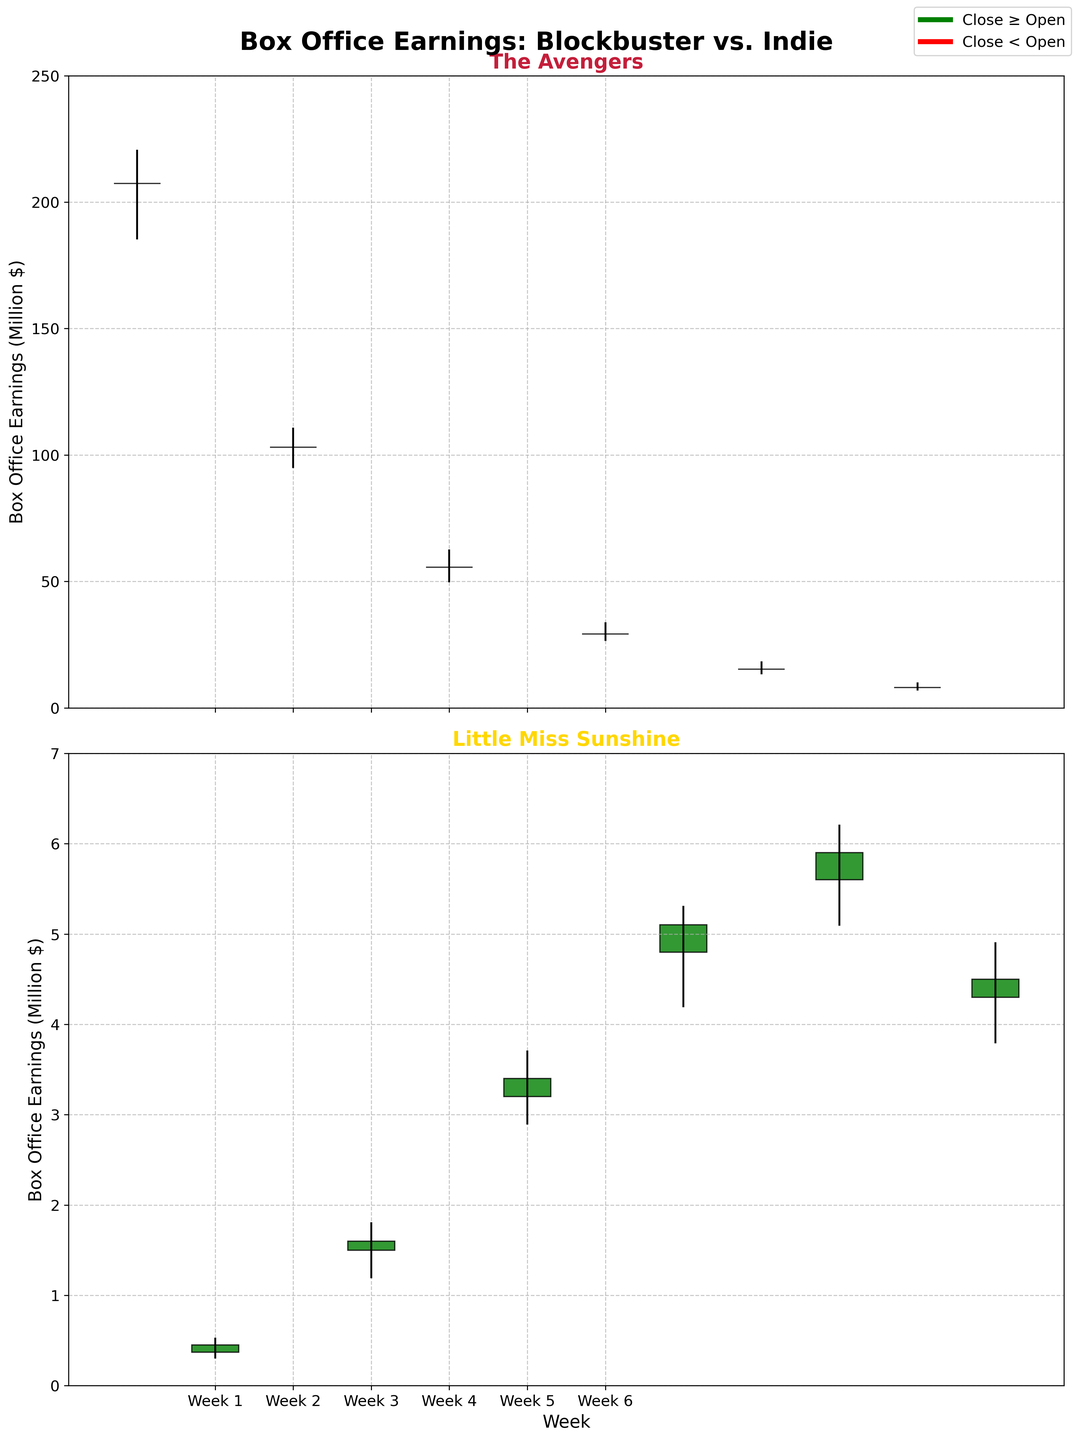What's the title of the plot? The title is displayed at the top of the plot. It reads "Box Office Earnings: Blockbuster vs. Indie".
Answer: Box Office Earnings: Blockbuster vs. Indie How many weeks are shown in the figure? The x-axis displays weeks labeled as "Week 1" to "Week 6", therefore there are 6 weeks shown.
Answer: 6 Which film had a higher opening earning in Week 1? Refer to the data points or rectangles on Week 1 for both films. "The Avengers" opened at 207.4 million, while "Little Miss Sunshine" opened at 0.37 million. Thus, "The Avengers" had a higher opening earning.
Answer: The Avengers Between Week 1 and Week 2 for "The Avengers", did the closing earnings increase or decrease? Look at the endpoints (tops) of the rectangles for "The Avengers" in Week 1 and Week 2 on the first plot. In Week 1, the close was 207.4, and in Week 2, the close was 103.1. This shows a decrease.
Answer: Decrease What is the difference between the highest earnings for "Little Miss Sunshine" and "The Avengers" in Week 4? The highest earnings in Week 4 for "The Avengers" is 33.5 million and for "Little Miss Sunshine" is 5.3 million. Subtract the two: 33.5 - 5.3 = 28.2 million.
Answer: 28.2 million During which week did "Little Miss Sunshine" have its highest weekly close? Inspect the second plot for the highest closing data point. "Little Miss Sunshine" reached its highest close of 5.9 million in Week 5.
Answer: Week 5 How many weeks did "The Avengers" end with a closing higher than its opening? Examine the colors of the rectangles in the first plot: green indicates close ≥ open. Green rectangles appear for Weeks 1 and 5. So, it happened in 2 weeks.
Answer: 2 Which week had the biggest range in earnings for "The Avengers"? Range is high minus low. Calculate for each week in the first plot. Week 1: 220.3 - 185.6; Week 2: 110.5 - 95.2; Week 3: 62.3 - 50.1; Week 4: 33.5 - 26.8; Week 5: 18.1 - 13.7; Week 6: 9.7 - 7.2. Week 1 has the highest range of 34.7 million.
Answer: Week 1 For Week 6, which film had a more stable range of earnings? Compare the lengths of the vertical lines in Week 6 for both films. The range for "The Avengers" is 9.7 - 7.2 = 2.5 million, and for "Little Miss Sunshine" is 4.9 - 3.8 = 1.1 million. "Little Miss Sunshine" had a more stable (narrower) range.
Answer: Little Miss Sunshine 